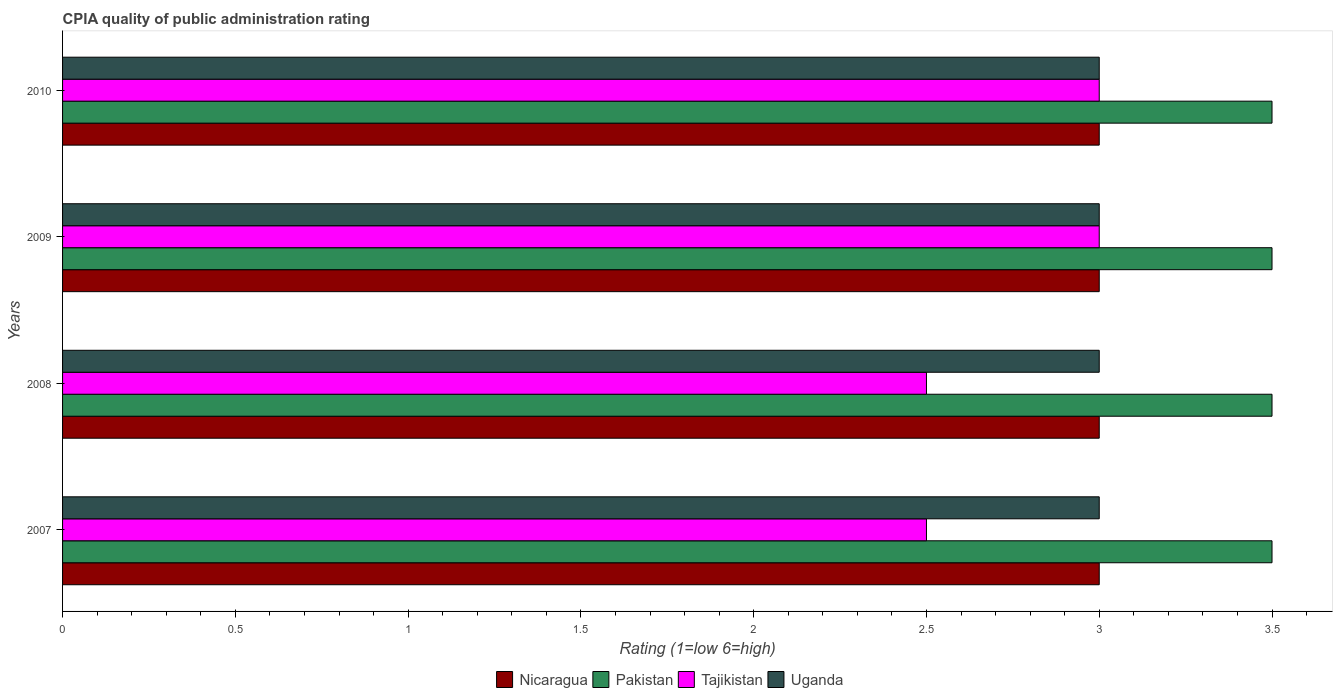How many different coloured bars are there?
Give a very brief answer. 4. How many groups of bars are there?
Ensure brevity in your answer.  4. Are the number of bars per tick equal to the number of legend labels?
Your response must be concise. Yes. Are the number of bars on each tick of the Y-axis equal?
Offer a terse response. Yes. What is the label of the 1st group of bars from the top?
Give a very brief answer. 2010. In how many cases, is the number of bars for a given year not equal to the number of legend labels?
Provide a succinct answer. 0. What is the CPIA rating in Uganda in 2007?
Provide a short and direct response. 3. Across all years, what is the minimum CPIA rating in Nicaragua?
Your answer should be very brief. 3. In which year was the CPIA rating in Pakistan minimum?
Make the answer very short. 2007. What is the total CPIA rating in Tajikistan in the graph?
Offer a terse response. 11. What is the difference between the CPIA rating in Pakistan in 2009 and the CPIA rating in Nicaragua in 2008?
Offer a very short reply. 0.5. In the year 2008, what is the difference between the CPIA rating in Nicaragua and CPIA rating in Pakistan?
Offer a terse response. -0.5. In how many years, is the CPIA rating in Nicaragua greater than 0.9 ?
Give a very brief answer. 4. What is the ratio of the CPIA rating in Uganda in 2007 to that in 2010?
Offer a very short reply. 1. What is the difference between the highest and the second highest CPIA rating in Uganda?
Your answer should be compact. 0. What is the difference between the highest and the lowest CPIA rating in Pakistan?
Provide a succinct answer. 0. Is the sum of the CPIA rating in Uganda in 2007 and 2009 greater than the maximum CPIA rating in Nicaragua across all years?
Your answer should be very brief. Yes. Is it the case that in every year, the sum of the CPIA rating in Nicaragua and CPIA rating in Uganda is greater than the sum of CPIA rating in Pakistan and CPIA rating in Tajikistan?
Offer a terse response. No. What does the 4th bar from the bottom in 2010 represents?
Keep it short and to the point. Uganda. How many years are there in the graph?
Your response must be concise. 4. Does the graph contain any zero values?
Offer a terse response. No. Does the graph contain grids?
Your answer should be very brief. No. Where does the legend appear in the graph?
Provide a short and direct response. Bottom center. How many legend labels are there?
Make the answer very short. 4. What is the title of the graph?
Provide a succinct answer. CPIA quality of public administration rating. What is the label or title of the X-axis?
Your response must be concise. Rating (1=low 6=high). What is the Rating (1=low 6=high) in Nicaragua in 2007?
Your answer should be compact. 3. What is the Rating (1=low 6=high) in Tajikistan in 2007?
Provide a short and direct response. 2.5. What is the Rating (1=low 6=high) of Uganda in 2007?
Offer a very short reply. 3. What is the Rating (1=low 6=high) of Nicaragua in 2008?
Your answer should be very brief. 3. What is the Rating (1=low 6=high) in Pakistan in 2008?
Provide a succinct answer. 3.5. What is the Rating (1=low 6=high) in Tajikistan in 2008?
Offer a very short reply. 2.5. What is the Rating (1=low 6=high) of Nicaragua in 2009?
Your response must be concise. 3. What is the Rating (1=low 6=high) of Tajikistan in 2009?
Offer a very short reply. 3. What is the Rating (1=low 6=high) in Uganda in 2009?
Your answer should be very brief. 3. What is the Rating (1=low 6=high) in Nicaragua in 2010?
Your answer should be very brief. 3. What is the Rating (1=low 6=high) in Pakistan in 2010?
Offer a terse response. 3.5. Across all years, what is the maximum Rating (1=low 6=high) in Tajikistan?
Provide a short and direct response. 3. Across all years, what is the minimum Rating (1=low 6=high) of Pakistan?
Make the answer very short. 3.5. Across all years, what is the minimum Rating (1=low 6=high) in Tajikistan?
Keep it short and to the point. 2.5. Across all years, what is the minimum Rating (1=low 6=high) of Uganda?
Provide a short and direct response. 3. What is the total Rating (1=low 6=high) of Nicaragua in the graph?
Your response must be concise. 12. What is the total Rating (1=low 6=high) of Pakistan in the graph?
Give a very brief answer. 14. What is the total Rating (1=low 6=high) of Uganda in the graph?
Your answer should be compact. 12. What is the difference between the Rating (1=low 6=high) in Nicaragua in 2007 and that in 2008?
Your answer should be very brief. 0. What is the difference between the Rating (1=low 6=high) of Uganda in 2007 and that in 2008?
Your answer should be compact. 0. What is the difference between the Rating (1=low 6=high) in Nicaragua in 2007 and that in 2009?
Your answer should be compact. 0. What is the difference between the Rating (1=low 6=high) of Pakistan in 2007 and that in 2009?
Keep it short and to the point. 0. What is the difference between the Rating (1=low 6=high) in Uganda in 2007 and that in 2009?
Provide a succinct answer. 0. What is the difference between the Rating (1=low 6=high) of Nicaragua in 2007 and that in 2010?
Make the answer very short. 0. What is the difference between the Rating (1=low 6=high) of Pakistan in 2007 and that in 2010?
Provide a succinct answer. 0. What is the difference between the Rating (1=low 6=high) in Tajikistan in 2008 and that in 2009?
Your answer should be very brief. -0.5. What is the difference between the Rating (1=low 6=high) of Uganda in 2008 and that in 2009?
Keep it short and to the point. 0. What is the difference between the Rating (1=low 6=high) of Pakistan in 2008 and that in 2010?
Your response must be concise. 0. What is the difference between the Rating (1=low 6=high) of Tajikistan in 2009 and that in 2010?
Your answer should be very brief. 0. What is the difference between the Rating (1=low 6=high) in Uganda in 2009 and that in 2010?
Your response must be concise. 0. What is the difference between the Rating (1=low 6=high) of Nicaragua in 2007 and the Rating (1=low 6=high) of Pakistan in 2008?
Your answer should be compact. -0.5. What is the difference between the Rating (1=low 6=high) in Nicaragua in 2007 and the Rating (1=low 6=high) in Tajikistan in 2008?
Your answer should be very brief. 0.5. What is the difference between the Rating (1=low 6=high) in Pakistan in 2007 and the Rating (1=low 6=high) in Tajikistan in 2009?
Give a very brief answer. 0.5. What is the difference between the Rating (1=low 6=high) in Nicaragua in 2007 and the Rating (1=low 6=high) in Uganda in 2010?
Provide a short and direct response. 0. What is the difference between the Rating (1=low 6=high) of Pakistan in 2007 and the Rating (1=low 6=high) of Tajikistan in 2010?
Your answer should be compact. 0.5. What is the difference between the Rating (1=low 6=high) of Pakistan in 2007 and the Rating (1=low 6=high) of Uganda in 2010?
Your response must be concise. 0.5. What is the difference between the Rating (1=low 6=high) in Nicaragua in 2008 and the Rating (1=low 6=high) in Tajikistan in 2009?
Provide a short and direct response. 0. What is the difference between the Rating (1=low 6=high) of Pakistan in 2008 and the Rating (1=low 6=high) of Tajikistan in 2009?
Provide a succinct answer. 0.5. What is the difference between the Rating (1=low 6=high) in Nicaragua in 2008 and the Rating (1=low 6=high) in Tajikistan in 2010?
Make the answer very short. 0. What is the difference between the Rating (1=low 6=high) of Nicaragua in 2008 and the Rating (1=low 6=high) of Uganda in 2010?
Your answer should be compact. 0. What is the difference between the Rating (1=low 6=high) of Nicaragua in 2009 and the Rating (1=low 6=high) of Pakistan in 2010?
Ensure brevity in your answer.  -0.5. What is the difference between the Rating (1=low 6=high) in Nicaragua in 2009 and the Rating (1=low 6=high) in Uganda in 2010?
Ensure brevity in your answer.  0. What is the difference between the Rating (1=low 6=high) in Pakistan in 2009 and the Rating (1=low 6=high) in Tajikistan in 2010?
Provide a succinct answer. 0.5. What is the difference between the Rating (1=low 6=high) in Tajikistan in 2009 and the Rating (1=low 6=high) in Uganda in 2010?
Keep it short and to the point. 0. What is the average Rating (1=low 6=high) of Nicaragua per year?
Your response must be concise. 3. What is the average Rating (1=low 6=high) in Pakistan per year?
Give a very brief answer. 3.5. What is the average Rating (1=low 6=high) in Tajikistan per year?
Offer a very short reply. 2.75. What is the average Rating (1=low 6=high) of Uganda per year?
Give a very brief answer. 3. In the year 2007, what is the difference between the Rating (1=low 6=high) in Nicaragua and Rating (1=low 6=high) in Pakistan?
Provide a succinct answer. -0.5. In the year 2007, what is the difference between the Rating (1=low 6=high) in Nicaragua and Rating (1=low 6=high) in Tajikistan?
Offer a very short reply. 0.5. In the year 2007, what is the difference between the Rating (1=low 6=high) in Pakistan and Rating (1=low 6=high) in Tajikistan?
Offer a terse response. 1. In the year 2007, what is the difference between the Rating (1=low 6=high) in Tajikistan and Rating (1=low 6=high) in Uganda?
Offer a terse response. -0.5. In the year 2008, what is the difference between the Rating (1=low 6=high) in Nicaragua and Rating (1=low 6=high) in Uganda?
Offer a terse response. 0. In the year 2009, what is the difference between the Rating (1=low 6=high) in Nicaragua and Rating (1=low 6=high) in Tajikistan?
Your response must be concise. 0. In the year 2009, what is the difference between the Rating (1=low 6=high) in Pakistan and Rating (1=low 6=high) in Uganda?
Provide a short and direct response. 0.5. In the year 2009, what is the difference between the Rating (1=low 6=high) in Tajikistan and Rating (1=low 6=high) in Uganda?
Ensure brevity in your answer.  0. In the year 2010, what is the difference between the Rating (1=low 6=high) in Nicaragua and Rating (1=low 6=high) in Pakistan?
Offer a very short reply. -0.5. In the year 2010, what is the difference between the Rating (1=low 6=high) of Nicaragua and Rating (1=low 6=high) of Tajikistan?
Ensure brevity in your answer.  0. In the year 2010, what is the difference between the Rating (1=low 6=high) in Nicaragua and Rating (1=low 6=high) in Uganda?
Your answer should be compact. 0. In the year 2010, what is the difference between the Rating (1=low 6=high) of Pakistan and Rating (1=low 6=high) of Tajikistan?
Provide a short and direct response. 0.5. What is the ratio of the Rating (1=low 6=high) in Uganda in 2007 to that in 2008?
Make the answer very short. 1. What is the ratio of the Rating (1=low 6=high) of Nicaragua in 2007 to that in 2009?
Provide a succinct answer. 1. What is the ratio of the Rating (1=low 6=high) of Pakistan in 2007 to that in 2009?
Your response must be concise. 1. What is the ratio of the Rating (1=low 6=high) of Tajikistan in 2007 to that in 2009?
Your answer should be very brief. 0.83. What is the ratio of the Rating (1=low 6=high) in Nicaragua in 2007 to that in 2010?
Ensure brevity in your answer.  1. What is the ratio of the Rating (1=low 6=high) in Pakistan in 2007 to that in 2010?
Give a very brief answer. 1. What is the ratio of the Rating (1=low 6=high) in Uganda in 2007 to that in 2010?
Your response must be concise. 1. What is the ratio of the Rating (1=low 6=high) in Tajikistan in 2008 to that in 2010?
Your answer should be very brief. 0.83. What is the ratio of the Rating (1=low 6=high) of Nicaragua in 2009 to that in 2010?
Offer a terse response. 1. What is the ratio of the Rating (1=low 6=high) of Pakistan in 2009 to that in 2010?
Offer a very short reply. 1. What is the difference between the highest and the second highest Rating (1=low 6=high) of Pakistan?
Keep it short and to the point. 0. What is the difference between the highest and the second highest Rating (1=low 6=high) in Tajikistan?
Provide a succinct answer. 0. What is the difference between the highest and the lowest Rating (1=low 6=high) in Nicaragua?
Provide a short and direct response. 0. What is the difference between the highest and the lowest Rating (1=low 6=high) of Uganda?
Your answer should be very brief. 0. 